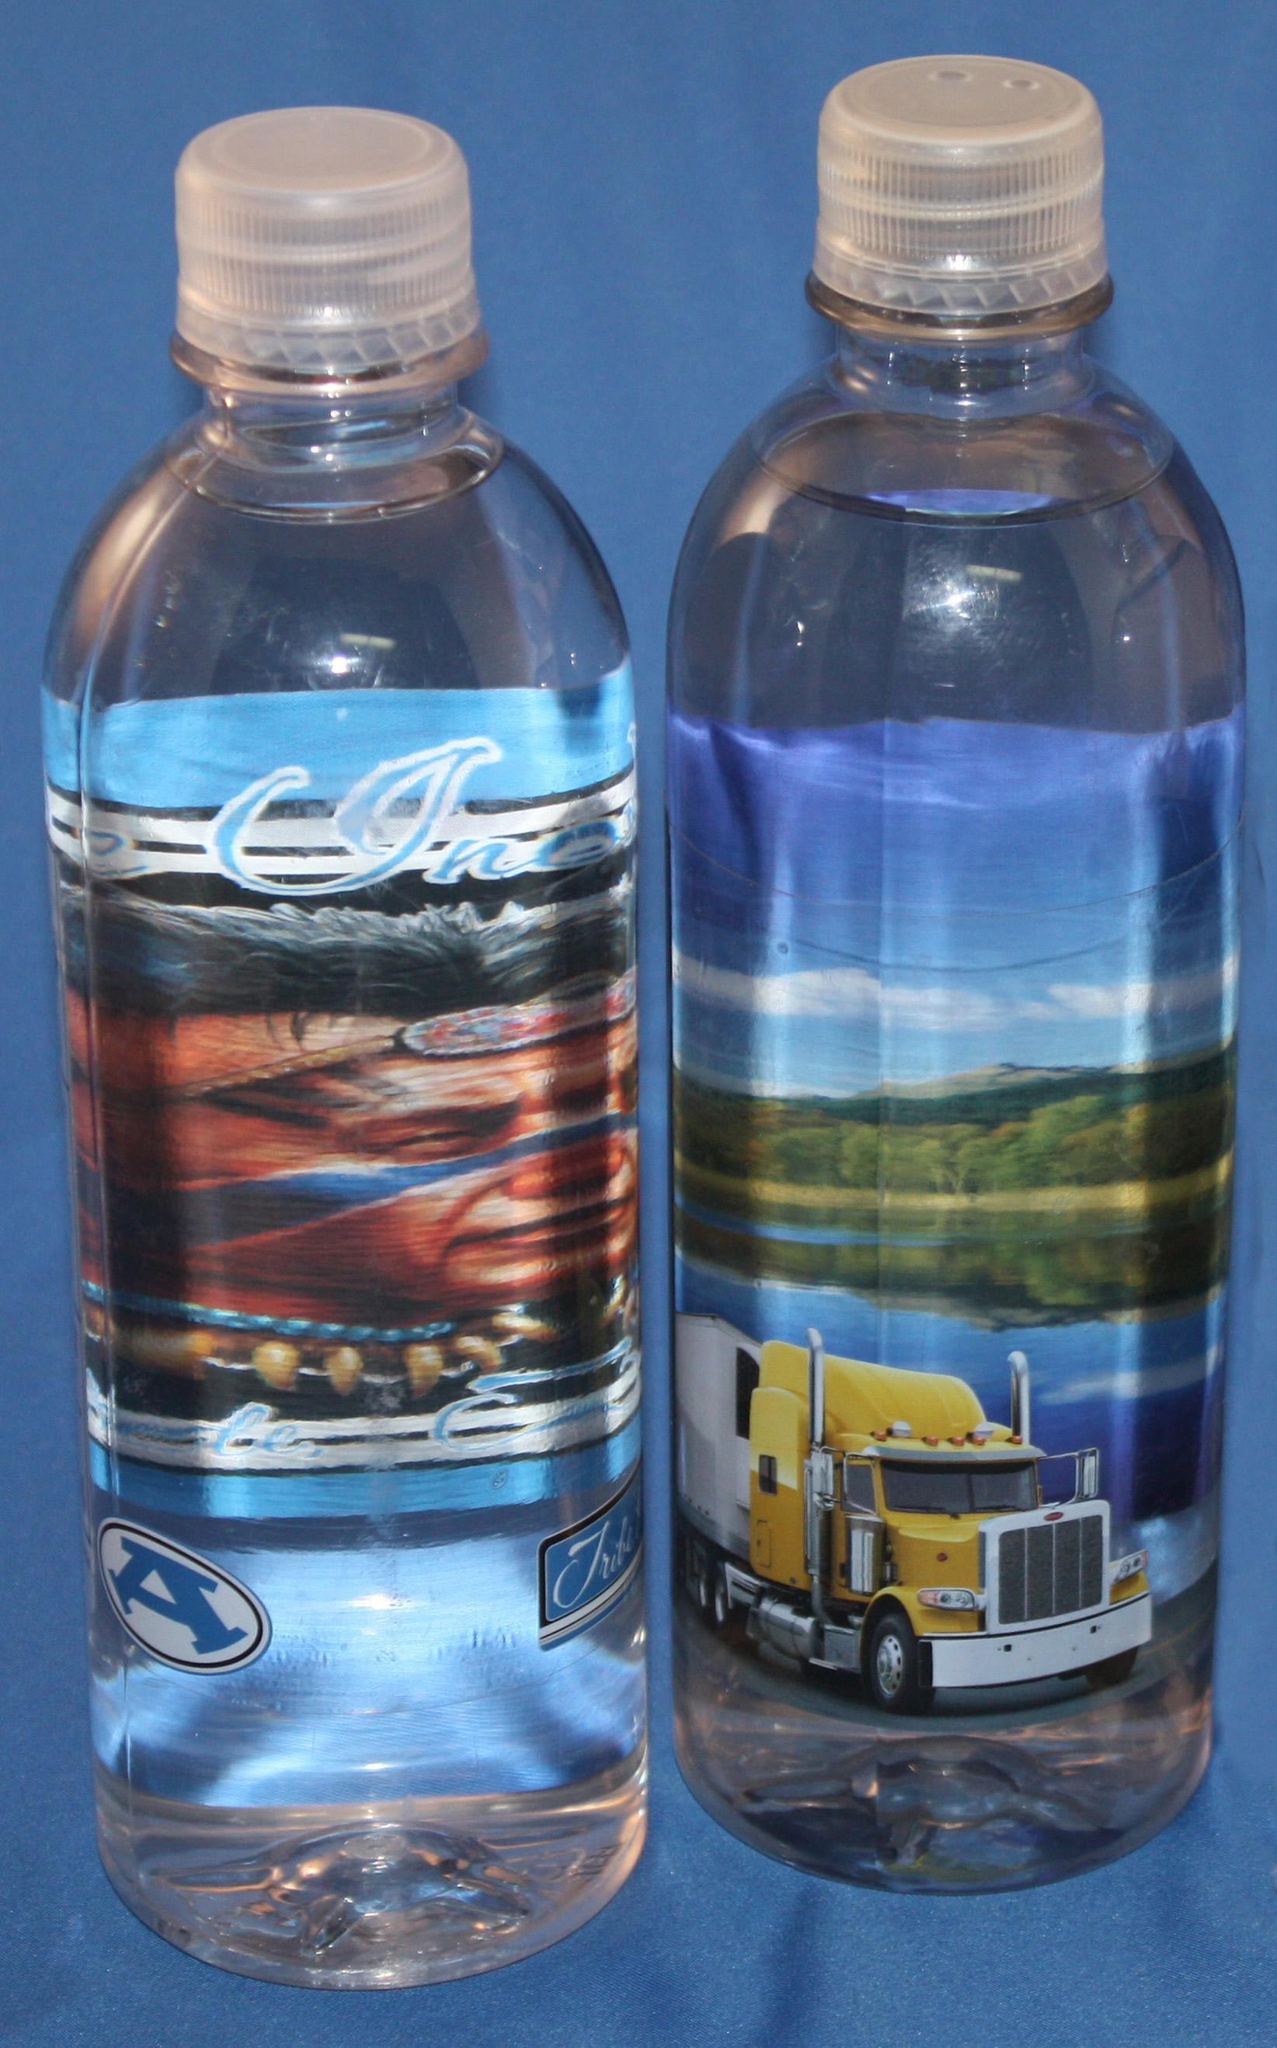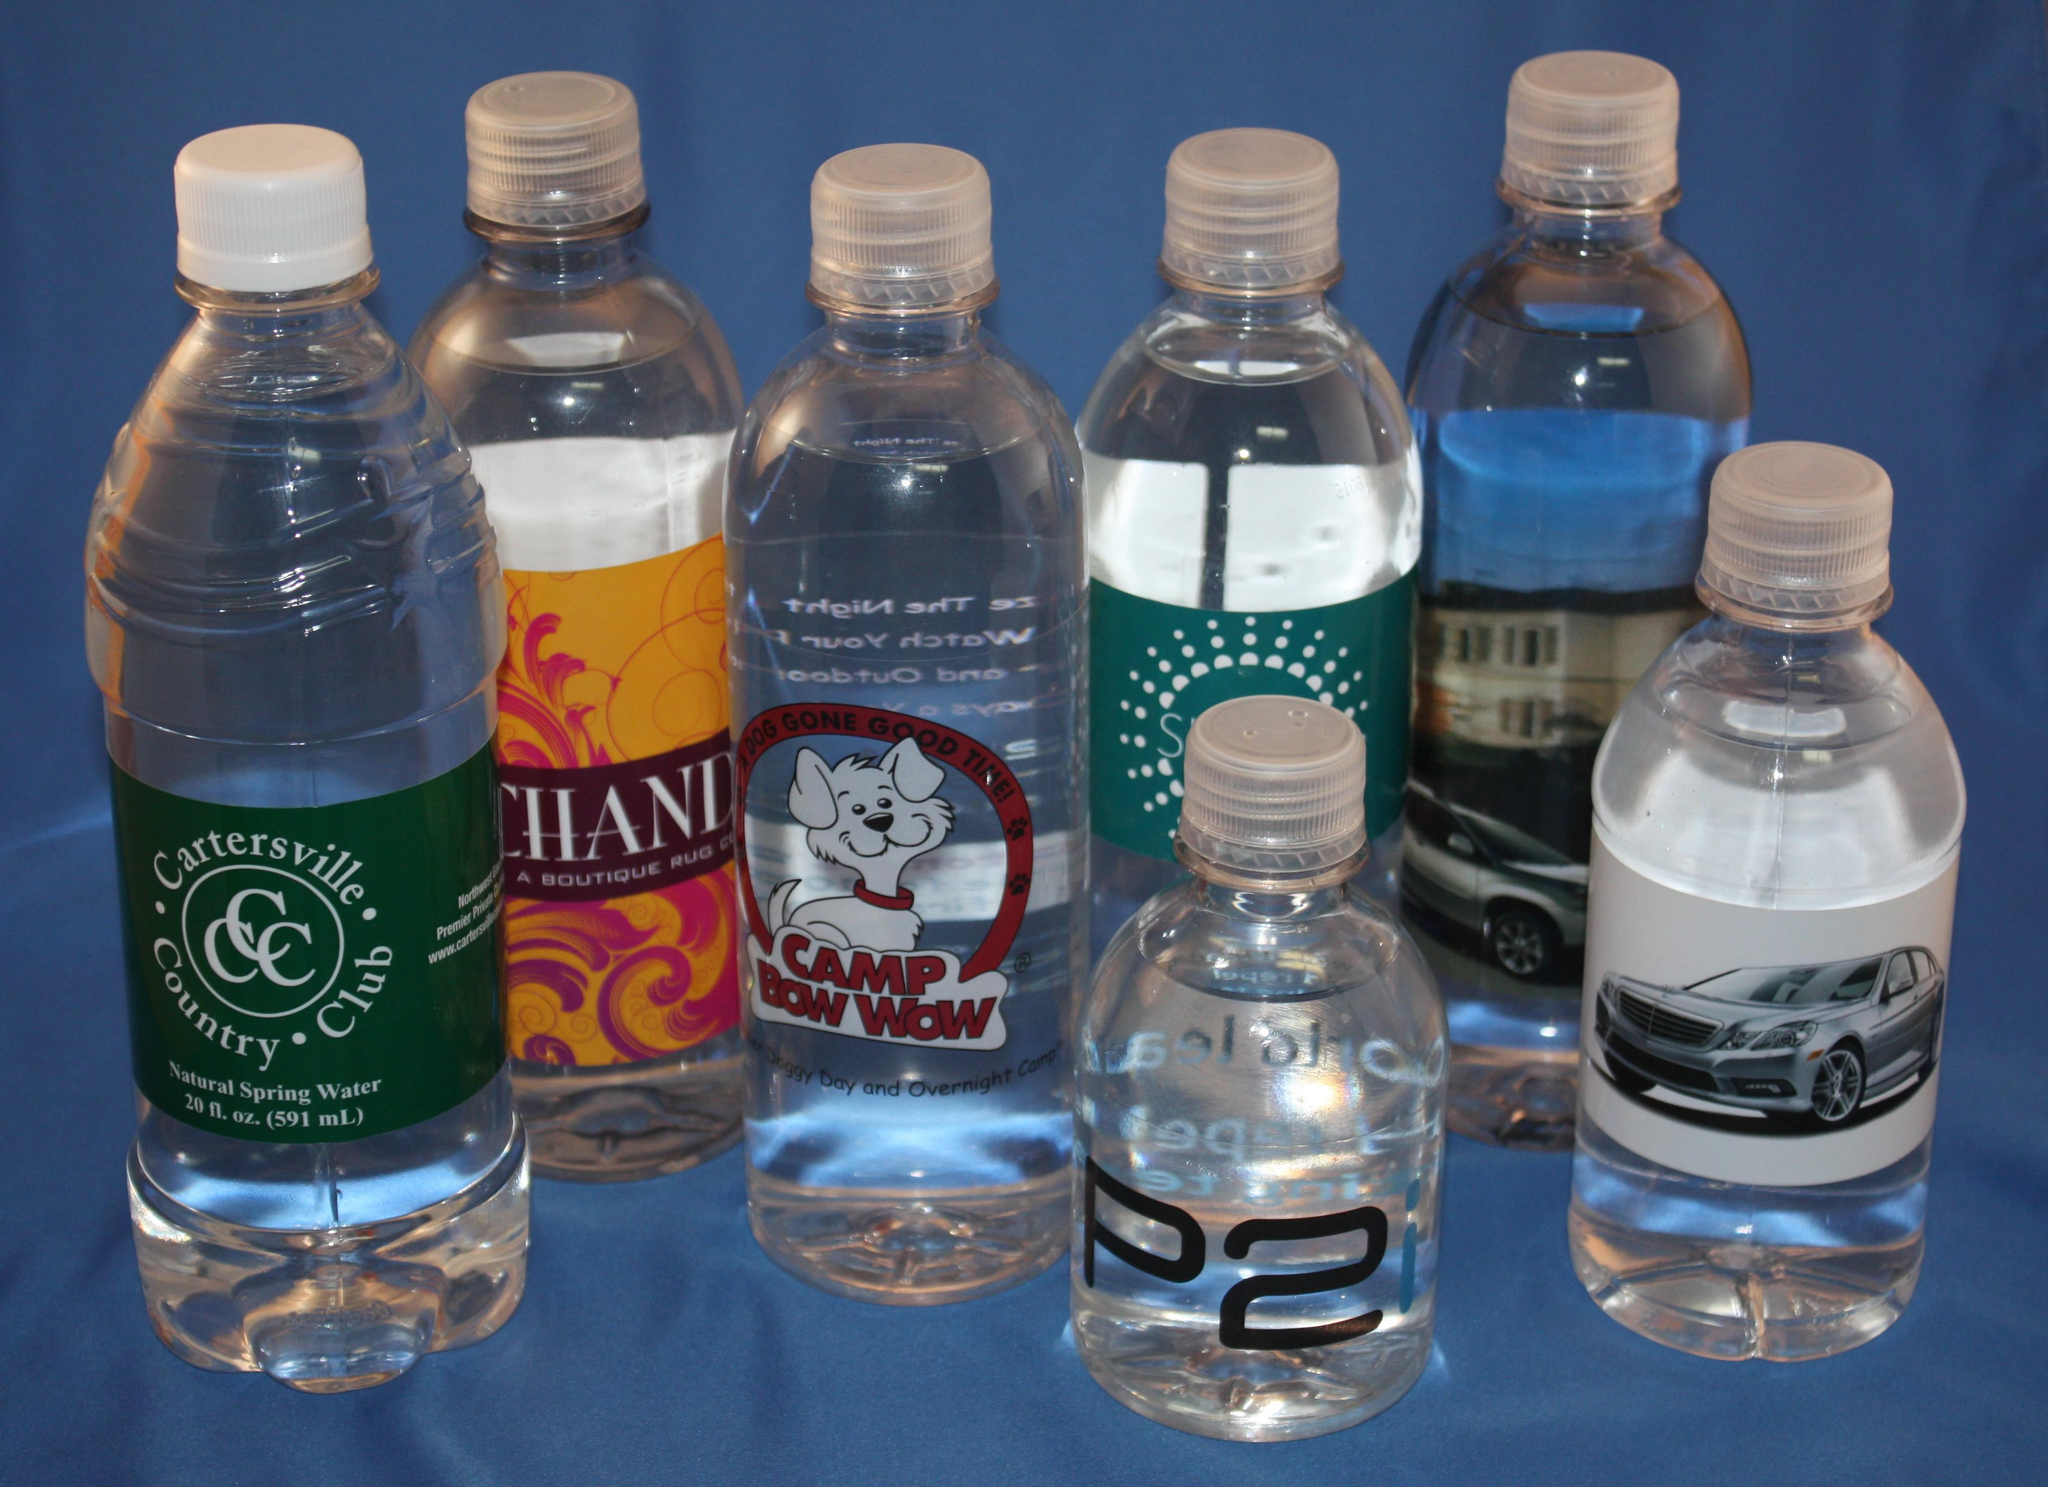The first image is the image on the left, the second image is the image on the right. Considering the images on both sides, is "The left and right image contains a total of six bottles." valid? Answer yes or no. No. The first image is the image on the left, the second image is the image on the right. Given the left and right images, does the statement "One image contains exactly two bottles displayed level and head-on, and the other image includes at least four identical bottles with identical labels." hold true? Answer yes or no. No. 